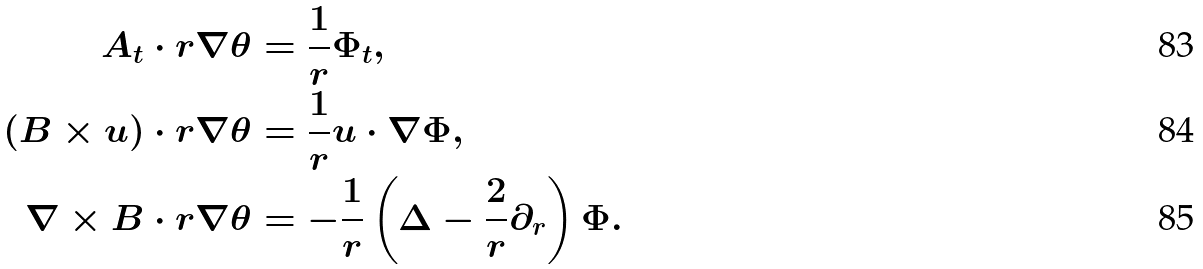Convert formula to latex. <formula><loc_0><loc_0><loc_500><loc_500>A _ { t } \cdot r \nabla \theta & = \frac { 1 } { r } \Phi _ { t } , \\ ( B \times u ) \cdot r \nabla \theta & = \frac { 1 } { r } u \cdot \nabla \Phi , \\ \nabla \times B \cdot r \nabla \theta & = - \frac { 1 } { r } \left ( \Delta - \frac { 2 } { r } \partial _ { r } \right ) \Phi .</formula> 